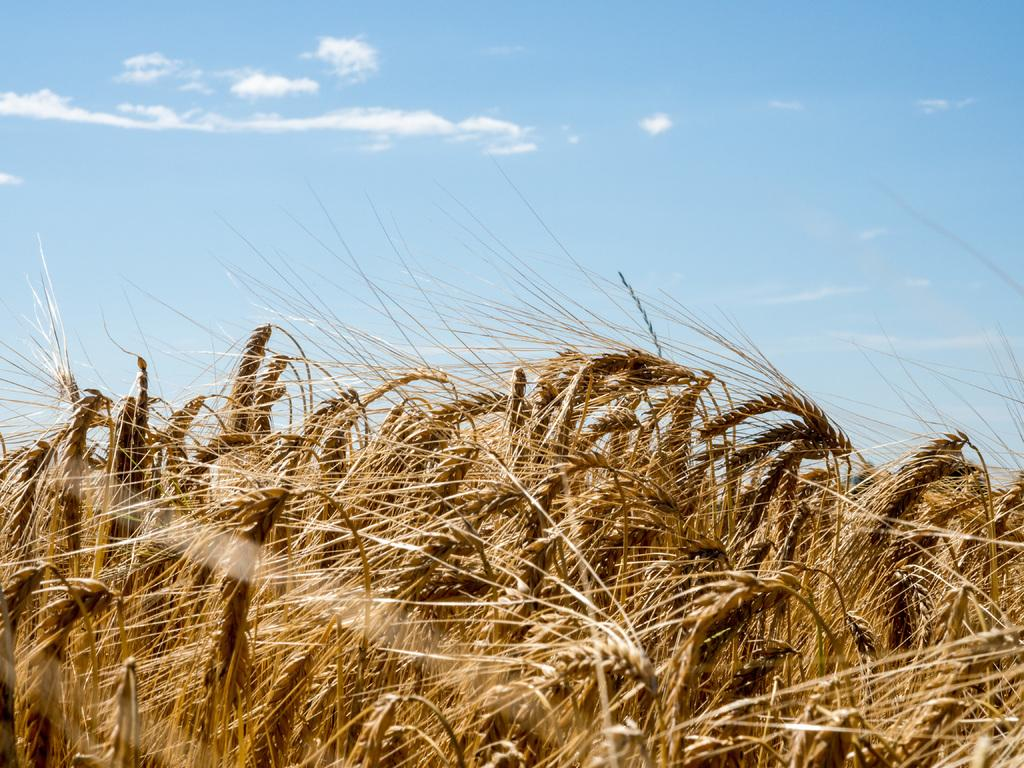What type of plants are visible in the image? There are plants with seeds in the image. What can be seen in the background of the image? There are clouds in the background of the image. What color is the sky in the image? The sky is blue in the image. How many slaves are visible in the image? There are no slaves present in the image. What type of steel is used to construct the plants in the image? The plants in the image are not made of steel; they are living organisms with seeds. 